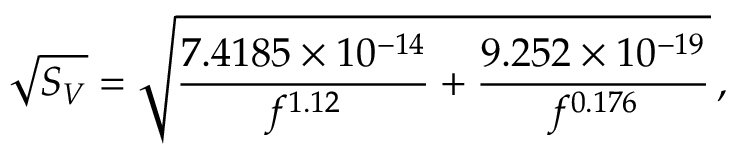Convert formula to latex. <formula><loc_0><loc_0><loc_500><loc_500>\sqrt { S _ { V } } = \sqrt { \frac { 7 . 4 1 8 5 \times 1 0 ^ { - 1 4 } } { f ^ { 1 . 1 2 } } + \frac { 9 . 2 5 2 \times 1 0 ^ { - 1 9 } } { f ^ { 0 . 1 7 6 } } } \, ,</formula> 